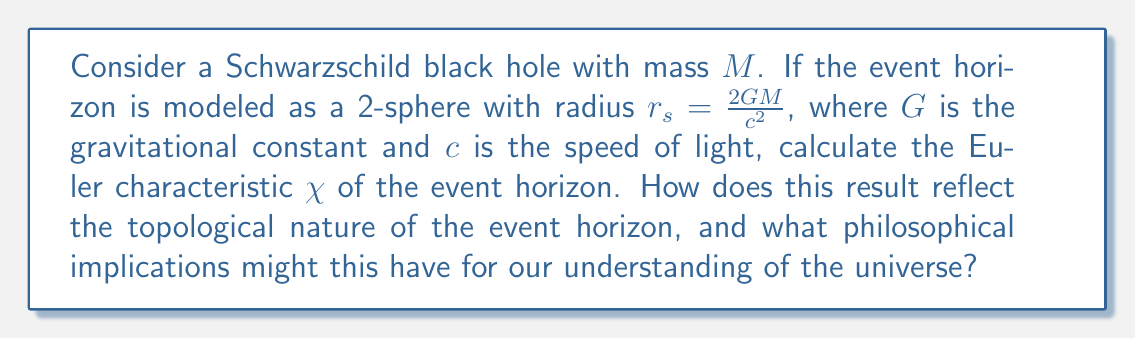Can you solve this math problem? To calculate the Euler characteristic of the event horizon, we will follow these steps:

1) The Euler characteristic $\chi$ for a 2-sphere is given by the formula:

   $$\chi = 2 - 2g$$

   where $g$ is the genus (number of holes) of the surface.

2) For a sphere, the genus $g = 0$, as it has no holes.

3) Substituting $g = 0$ into the formula:

   $$\chi = 2 - 2(0) = 2$$

4) This result, $\chi = 2$, is independent of the radius $r_s$ and thus independent of the mass $M$ of the black hole.

5) The Euler characteristic is a topological invariant, meaning it doesn't change under continuous deformations of the surface.

6) This implies that regardless of the size or mass of the Schwarzschild black hole, the event horizon always has the same fundamental shape (topology) as a sphere.

Philosophical Implications:
- The constancy of $\chi$ suggests a universal property of Schwarzschild black holes, independent of their physical parameters.
- This topological invariance might indicate a deeper, more fundamental nature of black holes beyond their physical characteristics.
- The sphere-like topology of the event horizon could be seen as a boundary between the known and unknown, reflecting our limited understanding of the universe.
- The simplicity of this result (always 2) contrasts with the complexity of black holes, raising questions about the relationship between mathematical simplicity and physical complexity in the universe.
Answer: $\chi = 2$, implying a sphere-like topology for all Schwarzschild black hole event horizons. 